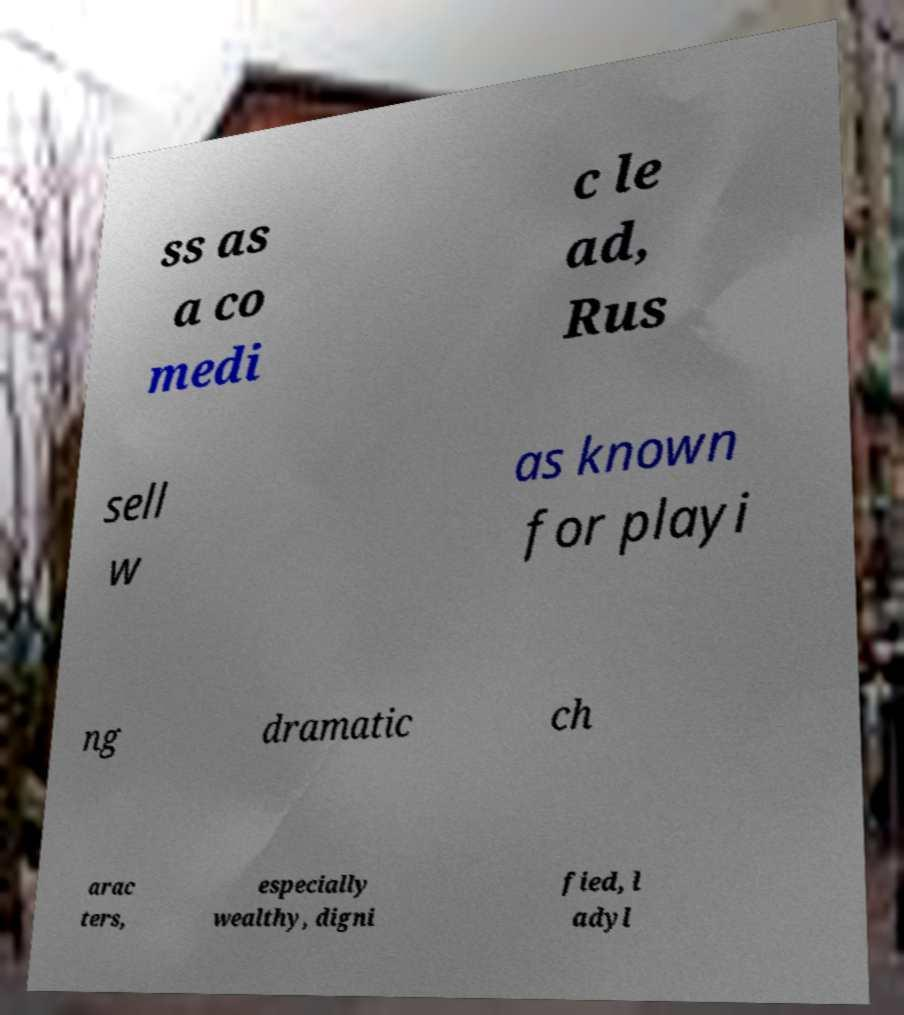For documentation purposes, I need the text within this image transcribed. Could you provide that? ss as a co medi c le ad, Rus sell w as known for playi ng dramatic ch arac ters, especially wealthy, digni fied, l adyl 